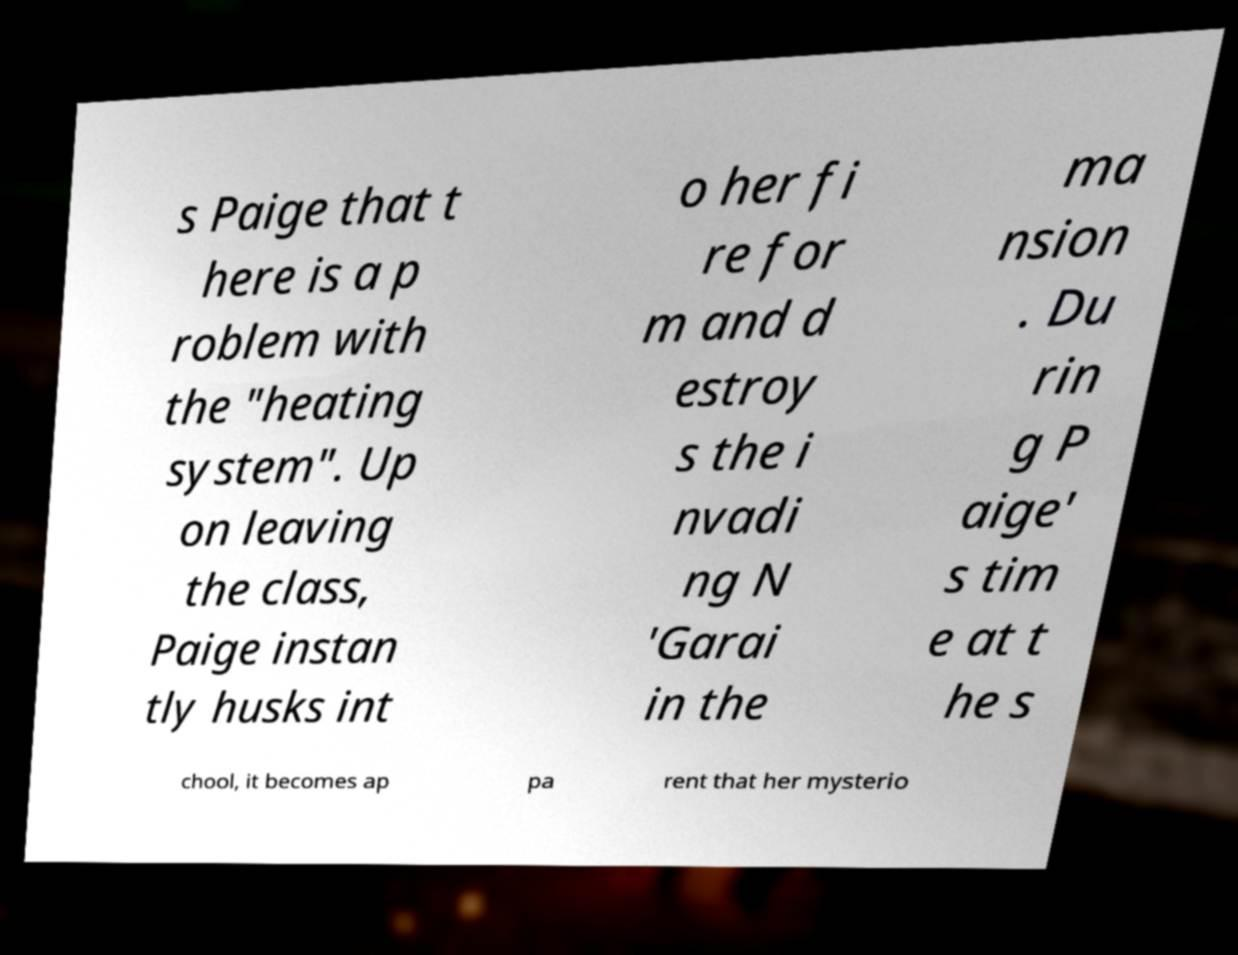Can you accurately transcribe the text from the provided image for me? s Paige that t here is a p roblem with the "heating system". Up on leaving the class, Paige instan tly husks int o her fi re for m and d estroy s the i nvadi ng N 'Garai in the ma nsion . Du rin g P aige' s tim e at t he s chool, it becomes ap pa rent that her mysterio 